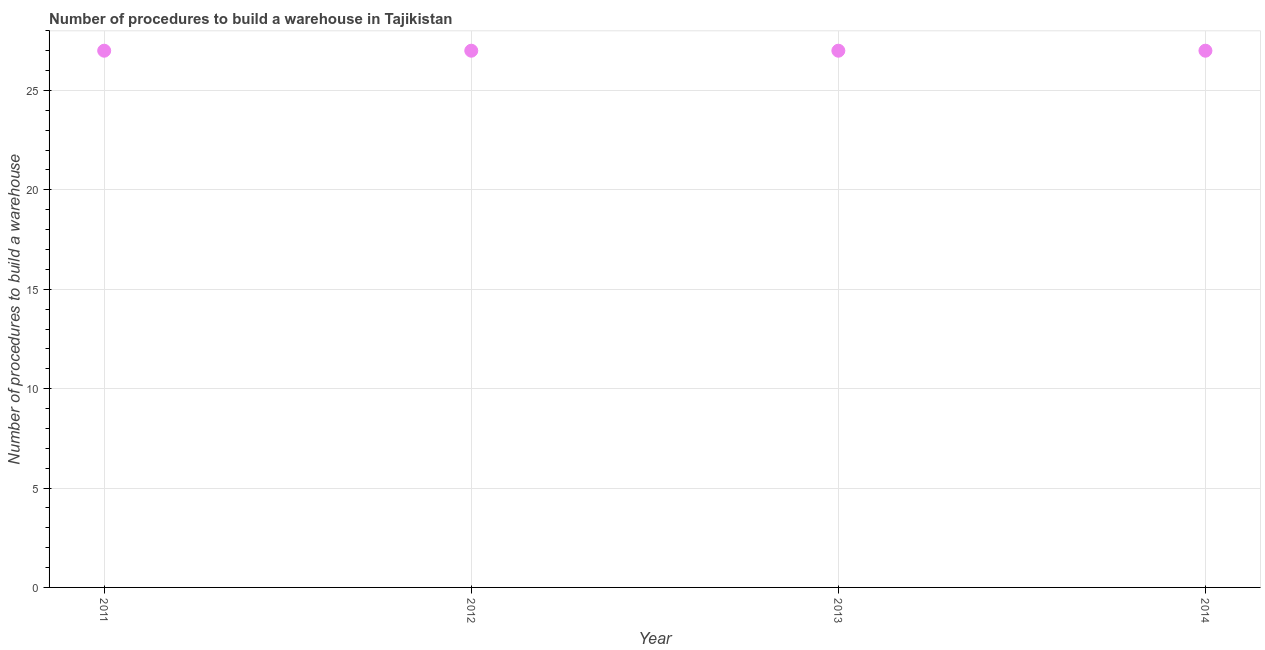What is the number of procedures to build a warehouse in 2013?
Your answer should be compact. 27. Across all years, what is the maximum number of procedures to build a warehouse?
Keep it short and to the point. 27. Across all years, what is the minimum number of procedures to build a warehouse?
Your answer should be very brief. 27. In which year was the number of procedures to build a warehouse minimum?
Provide a short and direct response. 2011. What is the sum of the number of procedures to build a warehouse?
Your answer should be compact. 108. In how many years, is the number of procedures to build a warehouse greater than 7 ?
Your answer should be compact. 4. What is the ratio of the number of procedures to build a warehouse in 2011 to that in 2014?
Offer a very short reply. 1. Is the number of procedures to build a warehouse in 2012 less than that in 2014?
Your answer should be very brief. No. What is the difference between the highest and the second highest number of procedures to build a warehouse?
Provide a short and direct response. 0. What is the difference between the highest and the lowest number of procedures to build a warehouse?
Give a very brief answer. 0. In how many years, is the number of procedures to build a warehouse greater than the average number of procedures to build a warehouse taken over all years?
Your answer should be compact. 0. Are the values on the major ticks of Y-axis written in scientific E-notation?
Offer a very short reply. No. Does the graph contain any zero values?
Provide a succinct answer. No. What is the title of the graph?
Your answer should be very brief. Number of procedures to build a warehouse in Tajikistan. What is the label or title of the Y-axis?
Your response must be concise. Number of procedures to build a warehouse. What is the Number of procedures to build a warehouse in 2011?
Your answer should be compact. 27. What is the Number of procedures to build a warehouse in 2013?
Provide a short and direct response. 27. What is the difference between the Number of procedures to build a warehouse in 2011 and 2012?
Keep it short and to the point. 0. What is the difference between the Number of procedures to build a warehouse in 2011 and 2013?
Offer a terse response. 0. What is the difference between the Number of procedures to build a warehouse in 2011 and 2014?
Offer a terse response. 0. What is the difference between the Number of procedures to build a warehouse in 2012 and 2013?
Give a very brief answer. 0. What is the difference between the Number of procedures to build a warehouse in 2012 and 2014?
Offer a terse response. 0. What is the difference between the Number of procedures to build a warehouse in 2013 and 2014?
Ensure brevity in your answer.  0. What is the ratio of the Number of procedures to build a warehouse in 2011 to that in 2013?
Give a very brief answer. 1. What is the ratio of the Number of procedures to build a warehouse in 2011 to that in 2014?
Your response must be concise. 1. What is the ratio of the Number of procedures to build a warehouse in 2012 to that in 2013?
Make the answer very short. 1. 